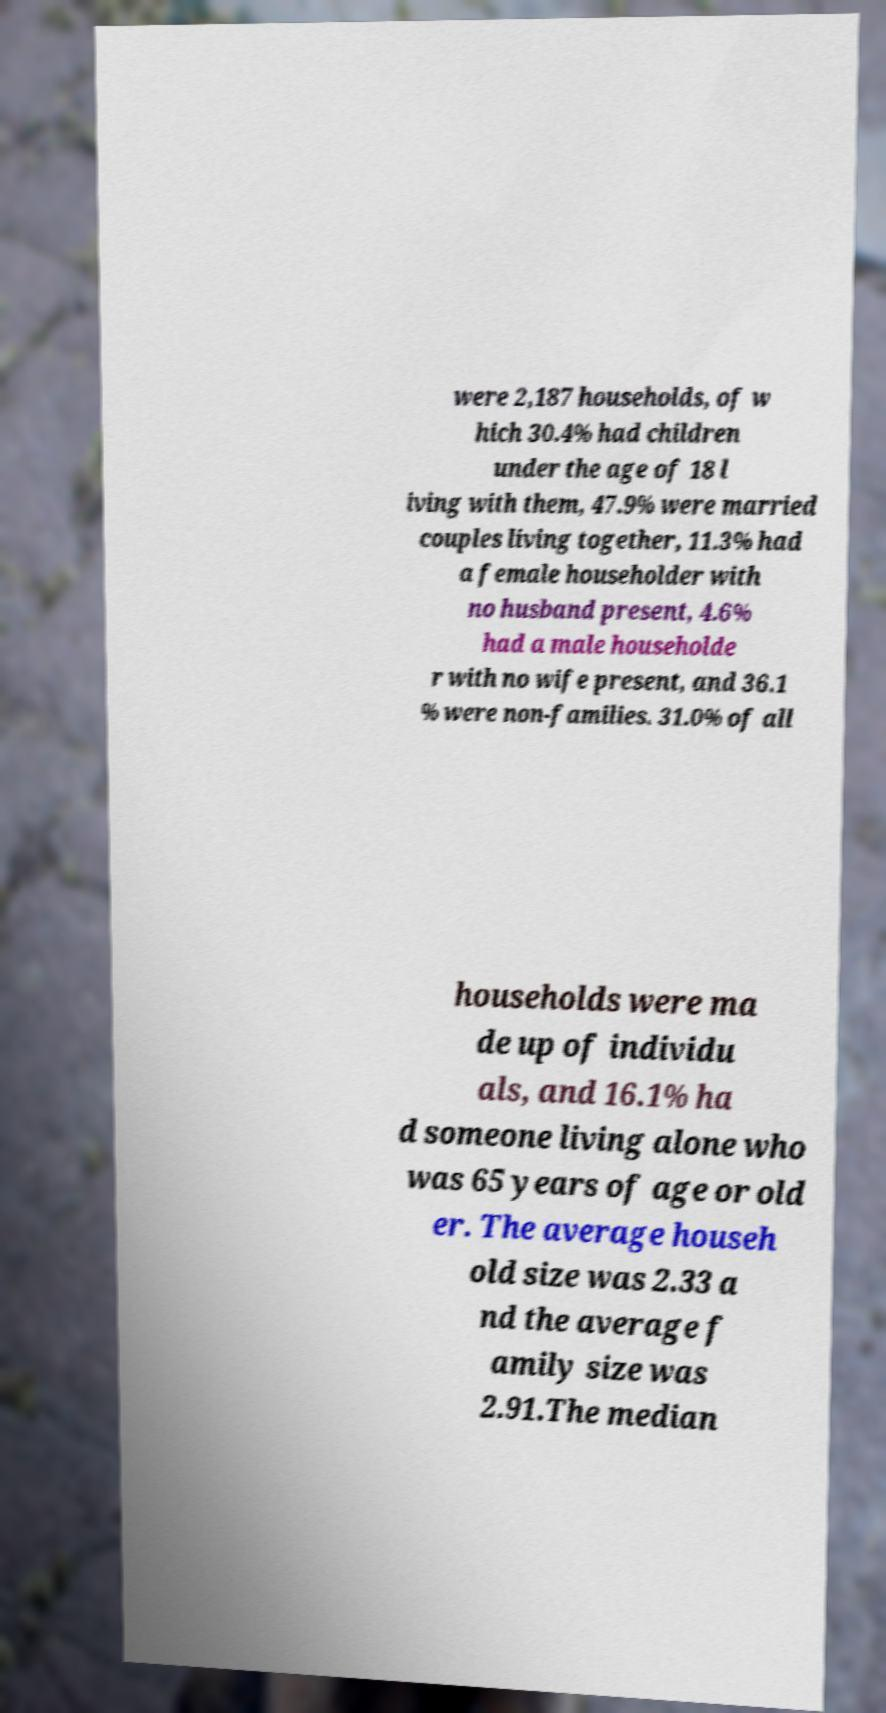Could you assist in decoding the text presented in this image and type it out clearly? were 2,187 households, of w hich 30.4% had children under the age of 18 l iving with them, 47.9% were married couples living together, 11.3% had a female householder with no husband present, 4.6% had a male householde r with no wife present, and 36.1 % were non-families. 31.0% of all households were ma de up of individu als, and 16.1% ha d someone living alone who was 65 years of age or old er. The average househ old size was 2.33 a nd the average f amily size was 2.91.The median 